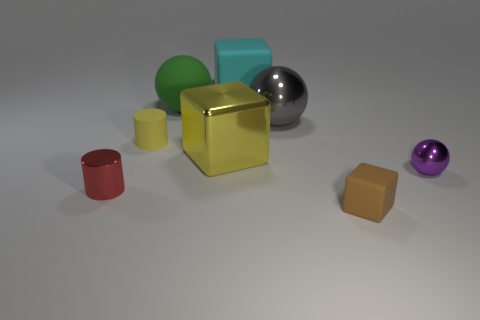There is a large metal cube; does it have the same color as the small thing behind the yellow metallic block?
Give a very brief answer. Yes. Are there any large metal things of the same color as the matte cylinder?
Provide a short and direct response. Yes. Does the small yellow cylinder have the same material as the sphere that is on the right side of the gray shiny sphere?
Offer a terse response. No. What number of big objects are gray shiny balls or metal things?
Your answer should be compact. 2. There is a large cube that is the same color as the matte cylinder; what is its material?
Provide a succinct answer. Metal. Are there fewer green matte things than metal spheres?
Your answer should be very brief. Yes. There is a ball left of the large yellow cube; is its size the same as the cylinder that is in front of the small yellow cylinder?
Provide a succinct answer. No. What number of green things are either small shiny cylinders or metal spheres?
Offer a very short reply. 0. What size is the thing that is the same color as the tiny rubber cylinder?
Your response must be concise. Large. Is the number of rubber balls greater than the number of purple shiny blocks?
Provide a succinct answer. Yes. 